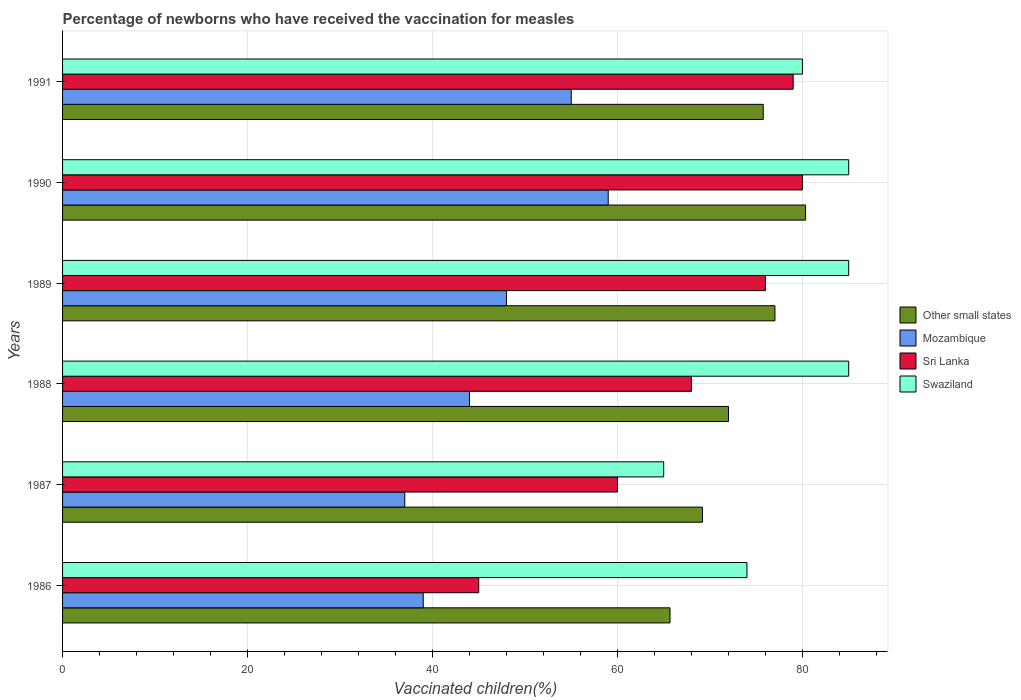How many groups of bars are there?
Keep it short and to the point. 6. Are the number of bars per tick equal to the number of legend labels?
Provide a succinct answer. Yes. Are the number of bars on each tick of the Y-axis equal?
Offer a terse response. Yes. What is the label of the 6th group of bars from the top?
Offer a very short reply. 1986. What is the percentage of vaccinated children in Swaziland in 1988?
Your response must be concise. 85. In which year was the percentage of vaccinated children in Other small states maximum?
Your answer should be compact. 1990. In which year was the percentage of vaccinated children in Swaziland minimum?
Ensure brevity in your answer.  1987. What is the total percentage of vaccinated children in Sri Lanka in the graph?
Your response must be concise. 408. What is the difference between the percentage of vaccinated children in Sri Lanka in 1986 and that in 1991?
Keep it short and to the point. -34. What is the average percentage of vaccinated children in Mozambique per year?
Provide a short and direct response. 47. In the year 1990, what is the difference between the percentage of vaccinated children in Mozambique and percentage of vaccinated children in Sri Lanka?
Give a very brief answer. -21. In how many years, is the percentage of vaccinated children in Swaziland greater than 48 %?
Provide a short and direct response. 6. What is the ratio of the percentage of vaccinated children in Mozambique in 1987 to that in 1989?
Offer a terse response. 0.77. What is the difference between the highest and the second highest percentage of vaccinated children in Other small states?
Your response must be concise. 3.31. What is the difference between the highest and the lowest percentage of vaccinated children in Other small states?
Make the answer very short. 14.66. In how many years, is the percentage of vaccinated children in Other small states greater than the average percentage of vaccinated children in Other small states taken over all years?
Keep it short and to the point. 3. Is the sum of the percentage of vaccinated children in Swaziland in 1988 and 1991 greater than the maximum percentage of vaccinated children in Mozambique across all years?
Give a very brief answer. Yes. What does the 1st bar from the top in 1987 represents?
Keep it short and to the point. Swaziland. What does the 1st bar from the bottom in 1989 represents?
Your answer should be compact. Other small states. How many bars are there?
Your answer should be compact. 24. How many years are there in the graph?
Give a very brief answer. 6. Are the values on the major ticks of X-axis written in scientific E-notation?
Provide a short and direct response. No. Does the graph contain any zero values?
Make the answer very short. No. How many legend labels are there?
Your answer should be very brief. 4. How are the legend labels stacked?
Offer a very short reply. Vertical. What is the title of the graph?
Offer a terse response. Percentage of newborns who have received the vaccination for measles. What is the label or title of the X-axis?
Provide a succinct answer. Vaccinated children(%). What is the Vaccinated children(%) in Other small states in 1986?
Provide a short and direct response. 65.68. What is the Vaccinated children(%) in Sri Lanka in 1986?
Your answer should be very brief. 45. What is the Vaccinated children(%) in Swaziland in 1986?
Make the answer very short. 74. What is the Vaccinated children(%) of Other small states in 1987?
Make the answer very short. 69.19. What is the Vaccinated children(%) in Sri Lanka in 1987?
Offer a very short reply. 60. What is the Vaccinated children(%) of Swaziland in 1987?
Keep it short and to the point. 65. What is the Vaccinated children(%) in Other small states in 1988?
Provide a short and direct response. 72.01. What is the Vaccinated children(%) of Mozambique in 1988?
Offer a very short reply. 44. What is the Vaccinated children(%) in Swaziland in 1988?
Give a very brief answer. 85. What is the Vaccinated children(%) of Other small states in 1989?
Offer a terse response. 77.03. What is the Vaccinated children(%) in Swaziland in 1989?
Give a very brief answer. 85. What is the Vaccinated children(%) of Other small states in 1990?
Give a very brief answer. 80.34. What is the Vaccinated children(%) in Mozambique in 1990?
Your response must be concise. 59. What is the Vaccinated children(%) in Sri Lanka in 1990?
Your response must be concise. 80. What is the Vaccinated children(%) of Swaziland in 1990?
Ensure brevity in your answer.  85. What is the Vaccinated children(%) in Other small states in 1991?
Keep it short and to the point. 75.76. What is the Vaccinated children(%) in Mozambique in 1991?
Your answer should be very brief. 55. What is the Vaccinated children(%) in Sri Lanka in 1991?
Your answer should be compact. 79. Across all years, what is the maximum Vaccinated children(%) in Other small states?
Your answer should be very brief. 80.34. Across all years, what is the maximum Vaccinated children(%) of Swaziland?
Keep it short and to the point. 85. Across all years, what is the minimum Vaccinated children(%) in Other small states?
Offer a terse response. 65.68. Across all years, what is the minimum Vaccinated children(%) of Swaziland?
Offer a terse response. 65. What is the total Vaccinated children(%) of Other small states in the graph?
Ensure brevity in your answer.  440.01. What is the total Vaccinated children(%) in Mozambique in the graph?
Your response must be concise. 282. What is the total Vaccinated children(%) of Sri Lanka in the graph?
Provide a succinct answer. 408. What is the total Vaccinated children(%) of Swaziland in the graph?
Your answer should be compact. 474. What is the difference between the Vaccinated children(%) of Other small states in 1986 and that in 1987?
Provide a short and direct response. -3.51. What is the difference between the Vaccinated children(%) of Sri Lanka in 1986 and that in 1987?
Your answer should be very brief. -15. What is the difference between the Vaccinated children(%) of Other small states in 1986 and that in 1988?
Provide a short and direct response. -6.33. What is the difference between the Vaccinated children(%) in Mozambique in 1986 and that in 1988?
Keep it short and to the point. -5. What is the difference between the Vaccinated children(%) of Sri Lanka in 1986 and that in 1988?
Provide a short and direct response. -23. What is the difference between the Vaccinated children(%) of Swaziland in 1986 and that in 1988?
Offer a very short reply. -11. What is the difference between the Vaccinated children(%) of Other small states in 1986 and that in 1989?
Offer a terse response. -11.35. What is the difference between the Vaccinated children(%) of Sri Lanka in 1986 and that in 1989?
Give a very brief answer. -31. What is the difference between the Vaccinated children(%) of Swaziland in 1986 and that in 1989?
Provide a succinct answer. -11. What is the difference between the Vaccinated children(%) of Other small states in 1986 and that in 1990?
Provide a succinct answer. -14.66. What is the difference between the Vaccinated children(%) in Mozambique in 1986 and that in 1990?
Your answer should be very brief. -20. What is the difference between the Vaccinated children(%) of Sri Lanka in 1986 and that in 1990?
Make the answer very short. -35. What is the difference between the Vaccinated children(%) in Other small states in 1986 and that in 1991?
Your answer should be very brief. -10.08. What is the difference between the Vaccinated children(%) of Mozambique in 1986 and that in 1991?
Give a very brief answer. -16. What is the difference between the Vaccinated children(%) in Sri Lanka in 1986 and that in 1991?
Offer a very short reply. -34. What is the difference between the Vaccinated children(%) of Swaziland in 1986 and that in 1991?
Provide a succinct answer. -6. What is the difference between the Vaccinated children(%) in Other small states in 1987 and that in 1988?
Keep it short and to the point. -2.82. What is the difference between the Vaccinated children(%) in Other small states in 1987 and that in 1989?
Provide a succinct answer. -7.84. What is the difference between the Vaccinated children(%) of Swaziland in 1987 and that in 1989?
Provide a succinct answer. -20. What is the difference between the Vaccinated children(%) in Other small states in 1987 and that in 1990?
Ensure brevity in your answer.  -11.15. What is the difference between the Vaccinated children(%) of Mozambique in 1987 and that in 1990?
Ensure brevity in your answer.  -22. What is the difference between the Vaccinated children(%) of Other small states in 1987 and that in 1991?
Your answer should be compact. -6.57. What is the difference between the Vaccinated children(%) in Mozambique in 1987 and that in 1991?
Keep it short and to the point. -18. What is the difference between the Vaccinated children(%) in Swaziland in 1987 and that in 1991?
Make the answer very short. -15. What is the difference between the Vaccinated children(%) of Other small states in 1988 and that in 1989?
Offer a very short reply. -5.02. What is the difference between the Vaccinated children(%) in Mozambique in 1988 and that in 1989?
Provide a short and direct response. -4. What is the difference between the Vaccinated children(%) in Sri Lanka in 1988 and that in 1989?
Provide a short and direct response. -8. What is the difference between the Vaccinated children(%) in Other small states in 1988 and that in 1990?
Your response must be concise. -8.33. What is the difference between the Vaccinated children(%) in Other small states in 1988 and that in 1991?
Ensure brevity in your answer.  -3.75. What is the difference between the Vaccinated children(%) of Mozambique in 1988 and that in 1991?
Your answer should be compact. -11. What is the difference between the Vaccinated children(%) in Swaziland in 1988 and that in 1991?
Ensure brevity in your answer.  5. What is the difference between the Vaccinated children(%) of Other small states in 1989 and that in 1990?
Provide a succinct answer. -3.31. What is the difference between the Vaccinated children(%) in Mozambique in 1989 and that in 1990?
Your answer should be very brief. -11. What is the difference between the Vaccinated children(%) in Sri Lanka in 1989 and that in 1990?
Give a very brief answer. -4. What is the difference between the Vaccinated children(%) in Swaziland in 1989 and that in 1990?
Your answer should be very brief. 0. What is the difference between the Vaccinated children(%) of Other small states in 1989 and that in 1991?
Keep it short and to the point. 1.26. What is the difference between the Vaccinated children(%) in Mozambique in 1989 and that in 1991?
Make the answer very short. -7. What is the difference between the Vaccinated children(%) in Other small states in 1990 and that in 1991?
Ensure brevity in your answer.  4.58. What is the difference between the Vaccinated children(%) in Other small states in 1986 and the Vaccinated children(%) in Mozambique in 1987?
Your answer should be compact. 28.68. What is the difference between the Vaccinated children(%) in Other small states in 1986 and the Vaccinated children(%) in Sri Lanka in 1987?
Your answer should be very brief. 5.68. What is the difference between the Vaccinated children(%) of Other small states in 1986 and the Vaccinated children(%) of Swaziland in 1987?
Offer a terse response. 0.68. What is the difference between the Vaccinated children(%) of Other small states in 1986 and the Vaccinated children(%) of Mozambique in 1988?
Your response must be concise. 21.68. What is the difference between the Vaccinated children(%) in Other small states in 1986 and the Vaccinated children(%) in Sri Lanka in 1988?
Give a very brief answer. -2.32. What is the difference between the Vaccinated children(%) in Other small states in 1986 and the Vaccinated children(%) in Swaziland in 1988?
Ensure brevity in your answer.  -19.32. What is the difference between the Vaccinated children(%) in Mozambique in 1986 and the Vaccinated children(%) in Sri Lanka in 1988?
Ensure brevity in your answer.  -29. What is the difference between the Vaccinated children(%) in Mozambique in 1986 and the Vaccinated children(%) in Swaziland in 1988?
Your answer should be compact. -46. What is the difference between the Vaccinated children(%) of Sri Lanka in 1986 and the Vaccinated children(%) of Swaziland in 1988?
Your answer should be compact. -40. What is the difference between the Vaccinated children(%) of Other small states in 1986 and the Vaccinated children(%) of Mozambique in 1989?
Make the answer very short. 17.68. What is the difference between the Vaccinated children(%) in Other small states in 1986 and the Vaccinated children(%) in Sri Lanka in 1989?
Offer a very short reply. -10.32. What is the difference between the Vaccinated children(%) of Other small states in 1986 and the Vaccinated children(%) of Swaziland in 1989?
Make the answer very short. -19.32. What is the difference between the Vaccinated children(%) in Mozambique in 1986 and the Vaccinated children(%) in Sri Lanka in 1989?
Give a very brief answer. -37. What is the difference between the Vaccinated children(%) of Mozambique in 1986 and the Vaccinated children(%) of Swaziland in 1989?
Ensure brevity in your answer.  -46. What is the difference between the Vaccinated children(%) of Sri Lanka in 1986 and the Vaccinated children(%) of Swaziland in 1989?
Keep it short and to the point. -40. What is the difference between the Vaccinated children(%) in Other small states in 1986 and the Vaccinated children(%) in Mozambique in 1990?
Keep it short and to the point. 6.68. What is the difference between the Vaccinated children(%) in Other small states in 1986 and the Vaccinated children(%) in Sri Lanka in 1990?
Offer a very short reply. -14.32. What is the difference between the Vaccinated children(%) in Other small states in 1986 and the Vaccinated children(%) in Swaziland in 1990?
Ensure brevity in your answer.  -19.32. What is the difference between the Vaccinated children(%) in Mozambique in 1986 and the Vaccinated children(%) in Sri Lanka in 1990?
Your answer should be very brief. -41. What is the difference between the Vaccinated children(%) in Mozambique in 1986 and the Vaccinated children(%) in Swaziland in 1990?
Make the answer very short. -46. What is the difference between the Vaccinated children(%) in Other small states in 1986 and the Vaccinated children(%) in Mozambique in 1991?
Give a very brief answer. 10.68. What is the difference between the Vaccinated children(%) in Other small states in 1986 and the Vaccinated children(%) in Sri Lanka in 1991?
Ensure brevity in your answer.  -13.32. What is the difference between the Vaccinated children(%) in Other small states in 1986 and the Vaccinated children(%) in Swaziland in 1991?
Ensure brevity in your answer.  -14.32. What is the difference between the Vaccinated children(%) in Mozambique in 1986 and the Vaccinated children(%) in Sri Lanka in 1991?
Ensure brevity in your answer.  -40. What is the difference between the Vaccinated children(%) in Mozambique in 1986 and the Vaccinated children(%) in Swaziland in 1991?
Give a very brief answer. -41. What is the difference between the Vaccinated children(%) in Sri Lanka in 1986 and the Vaccinated children(%) in Swaziland in 1991?
Make the answer very short. -35. What is the difference between the Vaccinated children(%) in Other small states in 1987 and the Vaccinated children(%) in Mozambique in 1988?
Provide a short and direct response. 25.19. What is the difference between the Vaccinated children(%) in Other small states in 1987 and the Vaccinated children(%) in Sri Lanka in 1988?
Offer a very short reply. 1.19. What is the difference between the Vaccinated children(%) of Other small states in 1987 and the Vaccinated children(%) of Swaziland in 1988?
Offer a terse response. -15.81. What is the difference between the Vaccinated children(%) of Mozambique in 1987 and the Vaccinated children(%) of Sri Lanka in 1988?
Offer a very short reply. -31. What is the difference between the Vaccinated children(%) in Mozambique in 1987 and the Vaccinated children(%) in Swaziland in 1988?
Give a very brief answer. -48. What is the difference between the Vaccinated children(%) of Sri Lanka in 1987 and the Vaccinated children(%) of Swaziland in 1988?
Provide a short and direct response. -25. What is the difference between the Vaccinated children(%) of Other small states in 1987 and the Vaccinated children(%) of Mozambique in 1989?
Your answer should be compact. 21.19. What is the difference between the Vaccinated children(%) in Other small states in 1987 and the Vaccinated children(%) in Sri Lanka in 1989?
Make the answer very short. -6.81. What is the difference between the Vaccinated children(%) of Other small states in 1987 and the Vaccinated children(%) of Swaziland in 1989?
Provide a short and direct response. -15.81. What is the difference between the Vaccinated children(%) in Mozambique in 1987 and the Vaccinated children(%) in Sri Lanka in 1989?
Provide a succinct answer. -39. What is the difference between the Vaccinated children(%) in Mozambique in 1987 and the Vaccinated children(%) in Swaziland in 1989?
Give a very brief answer. -48. What is the difference between the Vaccinated children(%) in Sri Lanka in 1987 and the Vaccinated children(%) in Swaziland in 1989?
Offer a terse response. -25. What is the difference between the Vaccinated children(%) in Other small states in 1987 and the Vaccinated children(%) in Mozambique in 1990?
Your answer should be compact. 10.19. What is the difference between the Vaccinated children(%) in Other small states in 1987 and the Vaccinated children(%) in Sri Lanka in 1990?
Your response must be concise. -10.81. What is the difference between the Vaccinated children(%) in Other small states in 1987 and the Vaccinated children(%) in Swaziland in 1990?
Your answer should be very brief. -15.81. What is the difference between the Vaccinated children(%) in Mozambique in 1987 and the Vaccinated children(%) in Sri Lanka in 1990?
Provide a short and direct response. -43. What is the difference between the Vaccinated children(%) in Mozambique in 1987 and the Vaccinated children(%) in Swaziland in 1990?
Offer a very short reply. -48. What is the difference between the Vaccinated children(%) of Sri Lanka in 1987 and the Vaccinated children(%) of Swaziland in 1990?
Offer a terse response. -25. What is the difference between the Vaccinated children(%) of Other small states in 1987 and the Vaccinated children(%) of Mozambique in 1991?
Keep it short and to the point. 14.19. What is the difference between the Vaccinated children(%) of Other small states in 1987 and the Vaccinated children(%) of Sri Lanka in 1991?
Your answer should be very brief. -9.81. What is the difference between the Vaccinated children(%) in Other small states in 1987 and the Vaccinated children(%) in Swaziland in 1991?
Your response must be concise. -10.81. What is the difference between the Vaccinated children(%) in Mozambique in 1987 and the Vaccinated children(%) in Sri Lanka in 1991?
Make the answer very short. -42. What is the difference between the Vaccinated children(%) of Mozambique in 1987 and the Vaccinated children(%) of Swaziland in 1991?
Provide a short and direct response. -43. What is the difference between the Vaccinated children(%) in Sri Lanka in 1987 and the Vaccinated children(%) in Swaziland in 1991?
Provide a succinct answer. -20. What is the difference between the Vaccinated children(%) of Other small states in 1988 and the Vaccinated children(%) of Mozambique in 1989?
Make the answer very short. 24.01. What is the difference between the Vaccinated children(%) of Other small states in 1988 and the Vaccinated children(%) of Sri Lanka in 1989?
Offer a very short reply. -3.99. What is the difference between the Vaccinated children(%) in Other small states in 1988 and the Vaccinated children(%) in Swaziland in 1989?
Keep it short and to the point. -12.99. What is the difference between the Vaccinated children(%) of Mozambique in 1988 and the Vaccinated children(%) of Sri Lanka in 1989?
Provide a succinct answer. -32. What is the difference between the Vaccinated children(%) of Mozambique in 1988 and the Vaccinated children(%) of Swaziland in 1989?
Your answer should be compact. -41. What is the difference between the Vaccinated children(%) in Sri Lanka in 1988 and the Vaccinated children(%) in Swaziland in 1989?
Offer a very short reply. -17. What is the difference between the Vaccinated children(%) of Other small states in 1988 and the Vaccinated children(%) of Mozambique in 1990?
Offer a terse response. 13.01. What is the difference between the Vaccinated children(%) in Other small states in 1988 and the Vaccinated children(%) in Sri Lanka in 1990?
Provide a succinct answer. -7.99. What is the difference between the Vaccinated children(%) in Other small states in 1988 and the Vaccinated children(%) in Swaziland in 1990?
Provide a succinct answer. -12.99. What is the difference between the Vaccinated children(%) of Mozambique in 1988 and the Vaccinated children(%) of Sri Lanka in 1990?
Your response must be concise. -36. What is the difference between the Vaccinated children(%) of Mozambique in 1988 and the Vaccinated children(%) of Swaziland in 1990?
Give a very brief answer. -41. What is the difference between the Vaccinated children(%) in Sri Lanka in 1988 and the Vaccinated children(%) in Swaziland in 1990?
Give a very brief answer. -17. What is the difference between the Vaccinated children(%) in Other small states in 1988 and the Vaccinated children(%) in Mozambique in 1991?
Give a very brief answer. 17.01. What is the difference between the Vaccinated children(%) of Other small states in 1988 and the Vaccinated children(%) of Sri Lanka in 1991?
Your answer should be compact. -6.99. What is the difference between the Vaccinated children(%) in Other small states in 1988 and the Vaccinated children(%) in Swaziland in 1991?
Ensure brevity in your answer.  -7.99. What is the difference between the Vaccinated children(%) in Mozambique in 1988 and the Vaccinated children(%) in Sri Lanka in 1991?
Make the answer very short. -35. What is the difference between the Vaccinated children(%) in Mozambique in 1988 and the Vaccinated children(%) in Swaziland in 1991?
Provide a succinct answer. -36. What is the difference between the Vaccinated children(%) in Sri Lanka in 1988 and the Vaccinated children(%) in Swaziland in 1991?
Provide a short and direct response. -12. What is the difference between the Vaccinated children(%) of Other small states in 1989 and the Vaccinated children(%) of Mozambique in 1990?
Provide a succinct answer. 18.03. What is the difference between the Vaccinated children(%) in Other small states in 1989 and the Vaccinated children(%) in Sri Lanka in 1990?
Make the answer very short. -2.97. What is the difference between the Vaccinated children(%) of Other small states in 1989 and the Vaccinated children(%) of Swaziland in 1990?
Offer a terse response. -7.97. What is the difference between the Vaccinated children(%) in Mozambique in 1989 and the Vaccinated children(%) in Sri Lanka in 1990?
Ensure brevity in your answer.  -32. What is the difference between the Vaccinated children(%) in Mozambique in 1989 and the Vaccinated children(%) in Swaziland in 1990?
Provide a succinct answer. -37. What is the difference between the Vaccinated children(%) in Other small states in 1989 and the Vaccinated children(%) in Mozambique in 1991?
Ensure brevity in your answer.  22.03. What is the difference between the Vaccinated children(%) of Other small states in 1989 and the Vaccinated children(%) of Sri Lanka in 1991?
Make the answer very short. -1.97. What is the difference between the Vaccinated children(%) in Other small states in 1989 and the Vaccinated children(%) in Swaziland in 1991?
Ensure brevity in your answer.  -2.97. What is the difference between the Vaccinated children(%) of Mozambique in 1989 and the Vaccinated children(%) of Sri Lanka in 1991?
Provide a short and direct response. -31. What is the difference between the Vaccinated children(%) in Mozambique in 1989 and the Vaccinated children(%) in Swaziland in 1991?
Provide a short and direct response. -32. What is the difference between the Vaccinated children(%) of Sri Lanka in 1989 and the Vaccinated children(%) of Swaziland in 1991?
Give a very brief answer. -4. What is the difference between the Vaccinated children(%) in Other small states in 1990 and the Vaccinated children(%) in Mozambique in 1991?
Ensure brevity in your answer.  25.34. What is the difference between the Vaccinated children(%) of Other small states in 1990 and the Vaccinated children(%) of Sri Lanka in 1991?
Make the answer very short. 1.34. What is the difference between the Vaccinated children(%) of Other small states in 1990 and the Vaccinated children(%) of Swaziland in 1991?
Offer a very short reply. 0.34. What is the difference between the Vaccinated children(%) in Mozambique in 1990 and the Vaccinated children(%) in Sri Lanka in 1991?
Make the answer very short. -20. What is the difference between the Vaccinated children(%) in Mozambique in 1990 and the Vaccinated children(%) in Swaziland in 1991?
Your answer should be compact. -21. What is the difference between the Vaccinated children(%) in Sri Lanka in 1990 and the Vaccinated children(%) in Swaziland in 1991?
Give a very brief answer. 0. What is the average Vaccinated children(%) of Other small states per year?
Keep it short and to the point. 73.34. What is the average Vaccinated children(%) of Sri Lanka per year?
Offer a terse response. 68. What is the average Vaccinated children(%) in Swaziland per year?
Ensure brevity in your answer.  79. In the year 1986, what is the difference between the Vaccinated children(%) of Other small states and Vaccinated children(%) of Mozambique?
Provide a short and direct response. 26.68. In the year 1986, what is the difference between the Vaccinated children(%) of Other small states and Vaccinated children(%) of Sri Lanka?
Offer a very short reply. 20.68. In the year 1986, what is the difference between the Vaccinated children(%) of Other small states and Vaccinated children(%) of Swaziland?
Give a very brief answer. -8.32. In the year 1986, what is the difference between the Vaccinated children(%) in Mozambique and Vaccinated children(%) in Sri Lanka?
Ensure brevity in your answer.  -6. In the year 1986, what is the difference between the Vaccinated children(%) in Mozambique and Vaccinated children(%) in Swaziland?
Provide a succinct answer. -35. In the year 1986, what is the difference between the Vaccinated children(%) in Sri Lanka and Vaccinated children(%) in Swaziland?
Provide a succinct answer. -29. In the year 1987, what is the difference between the Vaccinated children(%) in Other small states and Vaccinated children(%) in Mozambique?
Provide a succinct answer. 32.19. In the year 1987, what is the difference between the Vaccinated children(%) of Other small states and Vaccinated children(%) of Sri Lanka?
Offer a very short reply. 9.19. In the year 1987, what is the difference between the Vaccinated children(%) in Other small states and Vaccinated children(%) in Swaziland?
Give a very brief answer. 4.19. In the year 1987, what is the difference between the Vaccinated children(%) in Mozambique and Vaccinated children(%) in Swaziland?
Your response must be concise. -28. In the year 1987, what is the difference between the Vaccinated children(%) of Sri Lanka and Vaccinated children(%) of Swaziland?
Your answer should be very brief. -5. In the year 1988, what is the difference between the Vaccinated children(%) in Other small states and Vaccinated children(%) in Mozambique?
Give a very brief answer. 28.01. In the year 1988, what is the difference between the Vaccinated children(%) of Other small states and Vaccinated children(%) of Sri Lanka?
Give a very brief answer. 4.01. In the year 1988, what is the difference between the Vaccinated children(%) of Other small states and Vaccinated children(%) of Swaziland?
Provide a succinct answer. -12.99. In the year 1988, what is the difference between the Vaccinated children(%) in Mozambique and Vaccinated children(%) in Swaziland?
Give a very brief answer. -41. In the year 1988, what is the difference between the Vaccinated children(%) of Sri Lanka and Vaccinated children(%) of Swaziland?
Provide a succinct answer. -17. In the year 1989, what is the difference between the Vaccinated children(%) of Other small states and Vaccinated children(%) of Mozambique?
Make the answer very short. 29.03. In the year 1989, what is the difference between the Vaccinated children(%) in Other small states and Vaccinated children(%) in Sri Lanka?
Provide a short and direct response. 1.03. In the year 1989, what is the difference between the Vaccinated children(%) in Other small states and Vaccinated children(%) in Swaziland?
Keep it short and to the point. -7.97. In the year 1989, what is the difference between the Vaccinated children(%) in Mozambique and Vaccinated children(%) in Sri Lanka?
Your answer should be compact. -28. In the year 1989, what is the difference between the Vaccinated children(%) of Mozambique and Vaccinated children(%) of Swaziland?
Ensure brevity in your answer.  -37. In the year 1989, what is the difference between the Vaccinated children(%) in Sri Lanka and Vaccinated children(%) in Swaziland?
Ensure brevity in your answer.  -9. In the year 1990, what is the difference between the Vaccinated children(%) in Other small states and Vaccinated children(%) in Mozambique?
Your answer should be very brief. 21.34. In the year 1990, what is the difference between the Vaccinated children(%) in Other small states and Vaccinated children(%) in Sri Lanka?
Give a very brief answer. 0.34. In the year 1990, what is the difference between the Vaccinated children(%) in Other small states and Vaccinated children(%) in Swaziland?
Make the answer very short. -4.66. In the year 1990, what is the difference between the Vaccinated children(%) in Mozambique and Vaccinated children(%) in Sri Lanka?
Offer a terse response. -21. In the year 1991, what is the difference between the Vaccinated children(%) of Other small states and Vaccinated children(%) of Mozambique?
Ensure brevity in your answer.  20.76. In the year 1991, what is the difference between the Vaccinated children(%) in Other small states and Vaccinated children(%) in Sri Lanka?
Your response must be concise. -3.24. In the year 1991, what is the difference between the Vaccinated children(%) in Other small states and Vaccinated children(%) in Swaziland?
Give a very brief answer. -4.24. In the year 1991, what is the difference between the Vaccinated children(%) in Mozambique and Vaccinated children(%) in Swaziland?
Your answer should be very brief. -25. In the year 1991, what is the difference between the Vaccinated children(%) in Sri Lanka and Vaccinated children(%) in Swaziland?
Give a very brief answer. -1. What is the ratio of the Vaccinated children(%) in Other small states in 1986 to that in 1987?
Your answer should be very brief. 0.95. What is the ratio of the Vaccinated children(%) in Mozambique in 1986 to that in 1987?
Ensure brevity in your answer.  1.05. What is the ratio of the Vaccinated children(%) in Sri Lanka in 1986 to that in 1987?
Make the answer very short. 0.75. What is the ratio of the Vaccinated children(%) in Swaziland in 1986 to that in 1987?
Offer a very short reply. 1.14. What is the ratio of the Vaccinated children(%) of Other small states in 1986 to that in 1988?
Ensure brevity in your answer.  0.91. What is the ratio of the Vaccinated children(%) of Mozambique in 1986 to that in 1988?
Give a very brief answer. 0.89. What is the ratio of the Vaccinated children(%) in Sri Lanka in 1986 to that in 1988?
Your answer should be very brief. 0.66. What is the ratio of the Vaccinated children(%) of Swaziland in 1986 to that in 1988?
Provide a short and direct response. 0.87. What is the ratio of the Vaccinated children(%) of Other small states in 1986 to that in 1989?
Your answer should be compact. 0.85. What is the ratio of the Vaccinated children(%) of Mozambique in 1986 to that in 1989?
Your answer should be compact. 0.81. What is the ratio of the Vaccinated children(%) of Sri Lanka in 1986 to that in 1989?
Offer a very short reply. 0.59. What is the ratio of the Vaccinated children(%) of Swaziland in 1986 to that in 1989?
Provide a succinct answer. 0.87. What is the ratio of the Vaccinated children(%) of Other small states in 1986 to that in 1990?
Offer a very short reply. 0.82. What is the ratio of the Vaccinated children(%) in Mozambique in 1986 to that in 1990?
Offer a terse response. 0.66. What is the ratio of the Vaccinated children(%) in Sri Lanka in 1986 to that in 1990?
Offer a terse response. 0.56. What is the ratio of the Vaccinated children(%) of Swaziland in 1986 to that in 1990?
Your response must be concise. 0.87. What is the ratio of the Vaccinated children(%) in Other small states in 1986 to that in 1991?
Provide a short and direct response. 0.87. What is the ratio of the Vaccinated children(%) of Mozambique in 1986 to that in 1991?
Make the answer very short. 0.71. What is the ratio of the Vaccinated children(%) in Sri Lanka in 1986 to that in 1991?
Make the answer very short. 0.57. What is the ratio of the Vaccinated children(%) of Swaziland in 1986 to that in 1991?
Keep it short and to the point. 0.93. What is the ratio of the Vaccinated children(%) in Other small states in 1987 to that in 1988?
Offer a very short reply. 0.96. What is the ratio of the Vaccinated children(%) of Mozambique in 1987 to that in 1988?
Ensure brevity in your answer.  0.84. What is the ratio of the Vaccinated children(%) in Sri Lanka in 1987 to that in 1988?
Your answer should be very brief. 0.88. What is the ratio of the Vaccinated children(%) of Swaziland in 1987 to that in 1988?
Your response must be concise. 0.76. What is the ratio of the Vaccinated children(%) in Other small states in 1987 to that in 1989?
Your answer should be very brief. 0.9. What is the ratio of the Vaccinated children(%) in Mozambique in 1987 to that in 1989?
Offer a very short reply. 0.77. What is the ratio of the Vaccinated children(%) in Sri Lanka in 1987 to that in 1989?
Ensure brevity in your answer.  0.79. What is the ratio of the Vaccinated children(%) of Swaziland in 1987 to that in 1989?
Offer a terse response. 0.76. What is the ratio of the Vaccinated children(%) in Other small states in 1987 to that in 1990?
Offer a very short reply. 0.86. What is the ratio of the Vaccinated children(%) of Mozambique in 1987 to that in 1990?
Your answer should be very brief. 0.63. What is the ratio of the Vaccinated children(%) of Swaziland in 1987 to that in 1990?
Keep it short and to the point. 0.76. What is the ratio of the Vaccinated children(%) in Other small states in 1987 to that in 1991?
Ensure brevity in your answer.  0.91. What is the ratio of the Vaccinated children(%) in Mozambique in 1987 to that in 1991?
Provide a short and direct response. 0.67. What is the ratio of the Vaccinated children(%) of Sri Lanka in 1987 to that in 1991?
Keep it short and to the point. 0.76. What is the ratio of the Vaccinated children(%) in Swaziland in 1987 to that in 1991?
Offer a terse response. 0.81. What is the ratio of the Vaccinated children(%) in Other small states in 1988 to that in 1989?
Keep it short and to the point. 0.93. What is the ratio of the Vaccinated children(%) of Mozambique in 1988 to that in 1989?
Ensure brevity in your answer.  0.92. What is the ratio of the Vaccinated children(%) in Sri Lanka in 1988 to that in 1989?
Provide a succinct answer. 0.89. What is the ratio of the Vaccinated children(%) in Other small states in 1988 to that in 1990?
Give a very brief answer. 0.9. What is the ratio of the Vaccinated children(%) in Mozambique in 1988 to that in 1990?
Your answer should be very brief. 0.75. What is the ratio of the Vaccinated children(%) of Sri Lanka in 1988 to that in 1990?
Make the answer very short. 0.85. What is the ratio of the Vaccinated children(%) of Swaziland in 1988 to that in 1990?
Make the answer very short. 1. What is the ratio of the Vaccinated children(%) of Other small states in 1988 to that in 1991?
Keep it short and to the point. 0.95. What is the ratio of the Vaccinated children(%) of Mozambique in 1988 to that in 1991?
Give a very brief answer. 0.8. What is the ratio of the Vaccinated children(%) of Sri Lanka in 1988 to that in 1991?
Ensure brevity in your answer.  0.86. What is the ratio of the Vaccinated children(%) in Other small states in 1989 to that in 1990?
Give a very brief answer. 0.96. What is the ratio of the Vaccinated children(%) of Mozambique in 1989 to that in 1990?
Your answer should be very brief. 0.81. What is the ratio of the Vaccinated children(%) in Sri Lanka in 1989 to that in 1990?
Offer a terse response. 0.95. What is the ratio of the Vaccinated children(%) in Swaziland in 1989 to that in 1990?
Give a very brief answer. 1. What is the ratio of the Vaccinated children(%) in Other small states in 1989 to that in 1991?
Make the answer very short. 1.02. What is the ratio of the Vaccinated children(%) in Mozambique in 1989 to that in 1991?
Provide a succinct answer. 0.87. What is the ratio of the Vaccinated children(%) of Sri Lanka in 1989 to that in 1991?
Your answer should be compact. 0.96. What is the ratio of the Vaccinated children(%) in Swaziland in 1989 to that in 1991?
Give a very brief answer. 1.06. What is the ratio of the Vaccinated children(%) of Other small states in 1990 to that in 1991?
Keep it short and to the point. 1.06. What is the ratio of the Vaccinated children(%) in Mozambique in 1990 to that in 1991?
Give a very brief answer. 1.07. What is the ratio of the Vaccinated children(%) of Sri Lanka in 1990 to that in 1991?
Provide a short and direct response. 1.01. What is the ratio of the Vaccinated children(%) of Swaziland in 1990 to that in 1991?
Your response must be concise. 1.06. What is the difference between the highest and the second highest Vaccinated children(%) in Other small states?
Your answer should be very brief. 3.31. What is the difference between the highest and the second highest Vaccinated children(%) in Sri Lanka?
Give a very brief answer. 1. What is the difference between the highest and the lowest Vaccinated children(%) of Other small states?
Offer a very short reply. 14.66. What is the difference between the highest and the lowest Vaccinated children(%) in Mozambique?
Give a very brief answer. 22. What is the difference between the highest and the lowest Vaccinated children(%) of Sri Lanka?
Make the answer very short. 35. What is the difference between the highest and the lowest Vaccinated children(%) of Swaziland?
Keep it short and to the point. 20. 